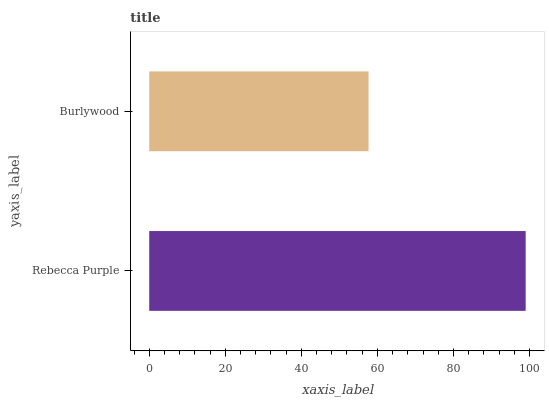Is Burlywood the minimum?
Answer yes or no. Yes. Is Rebecca Purple the maximum?
Answer yes or no. Yes. Is Burlywood the maximum?
Answer yes or no. No. Is Rebecca Purple greater than Burlywood?
Answer yes or no. Yes. Is Burlywood less than Rebecca Purple?
Answer yes or no. Yes. Is Burlywood greater than Rebecca Purple?
Answer yes or no. No. Is Rebecca Purple less than Burlywood?
Answer yes or no. No. Is Rebecca Purple the high median?
Answer yes or no. Yes. Is Burlywood the low median?
Answer yes or no. Yes. Is Burlywood the high median?
Answer yes or no. No. Is Rebecca Purple the low median?
Answer yes or no. No. 